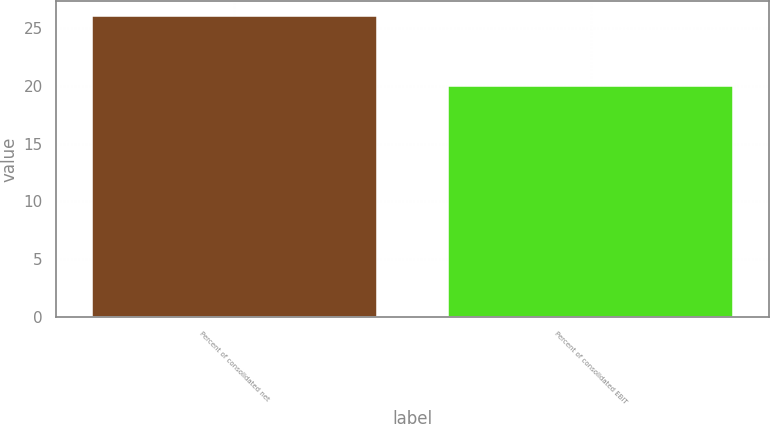Convert chart. <chart><loc_0><loc_0><loc_500><loc_500><bar_chart><fcel>Percent of consolidated net<fcel>Percent of consolidated EBIT<nl><fcel>26<fcel>20<nl></chart> 